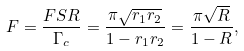<formula> <loc_0><loc_0><loc_500><loc_500>F = \frac { F S R } { \Gamma _ { c } } = \frac { \pi \sqrt { r _ { 1 } r _ { 2 } } } { 1 - r _ { 1 } r _ { 2 } } = \frac { \pi \sqrt { R } } { 1 - R } ,</formula> 